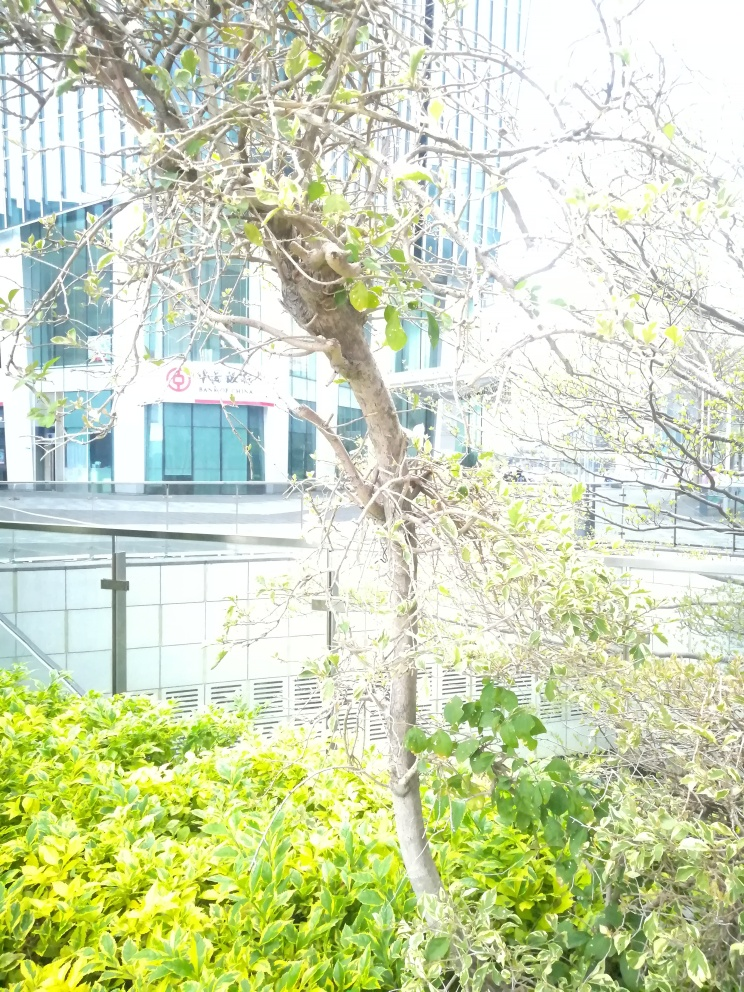Can you describe the style or architectural features of the building in the background? The building in the background features a modern architectural style with a reflective glass facade, linear design elements, and appears to be a commercial or office building given its structured and formal appearance. 